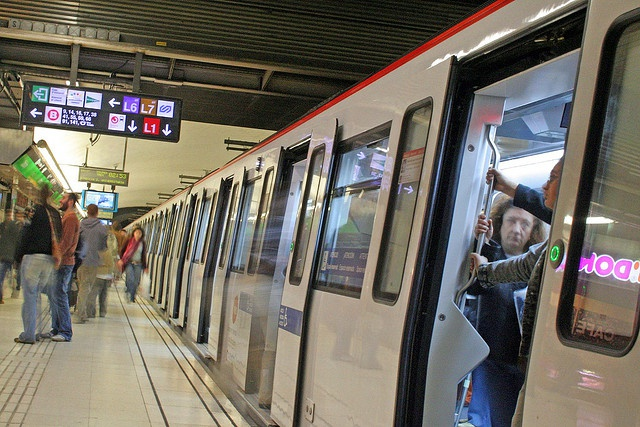Describe the objects in this image and their specific colors. I can see train in black, darkgray, and gray tones, people in black, gray, navy, and darkgray tones, people in black and gray tones, people in black, gray, maroon, and darkgray tones, and people in black, gray, maroon, and brown tones in this image. 